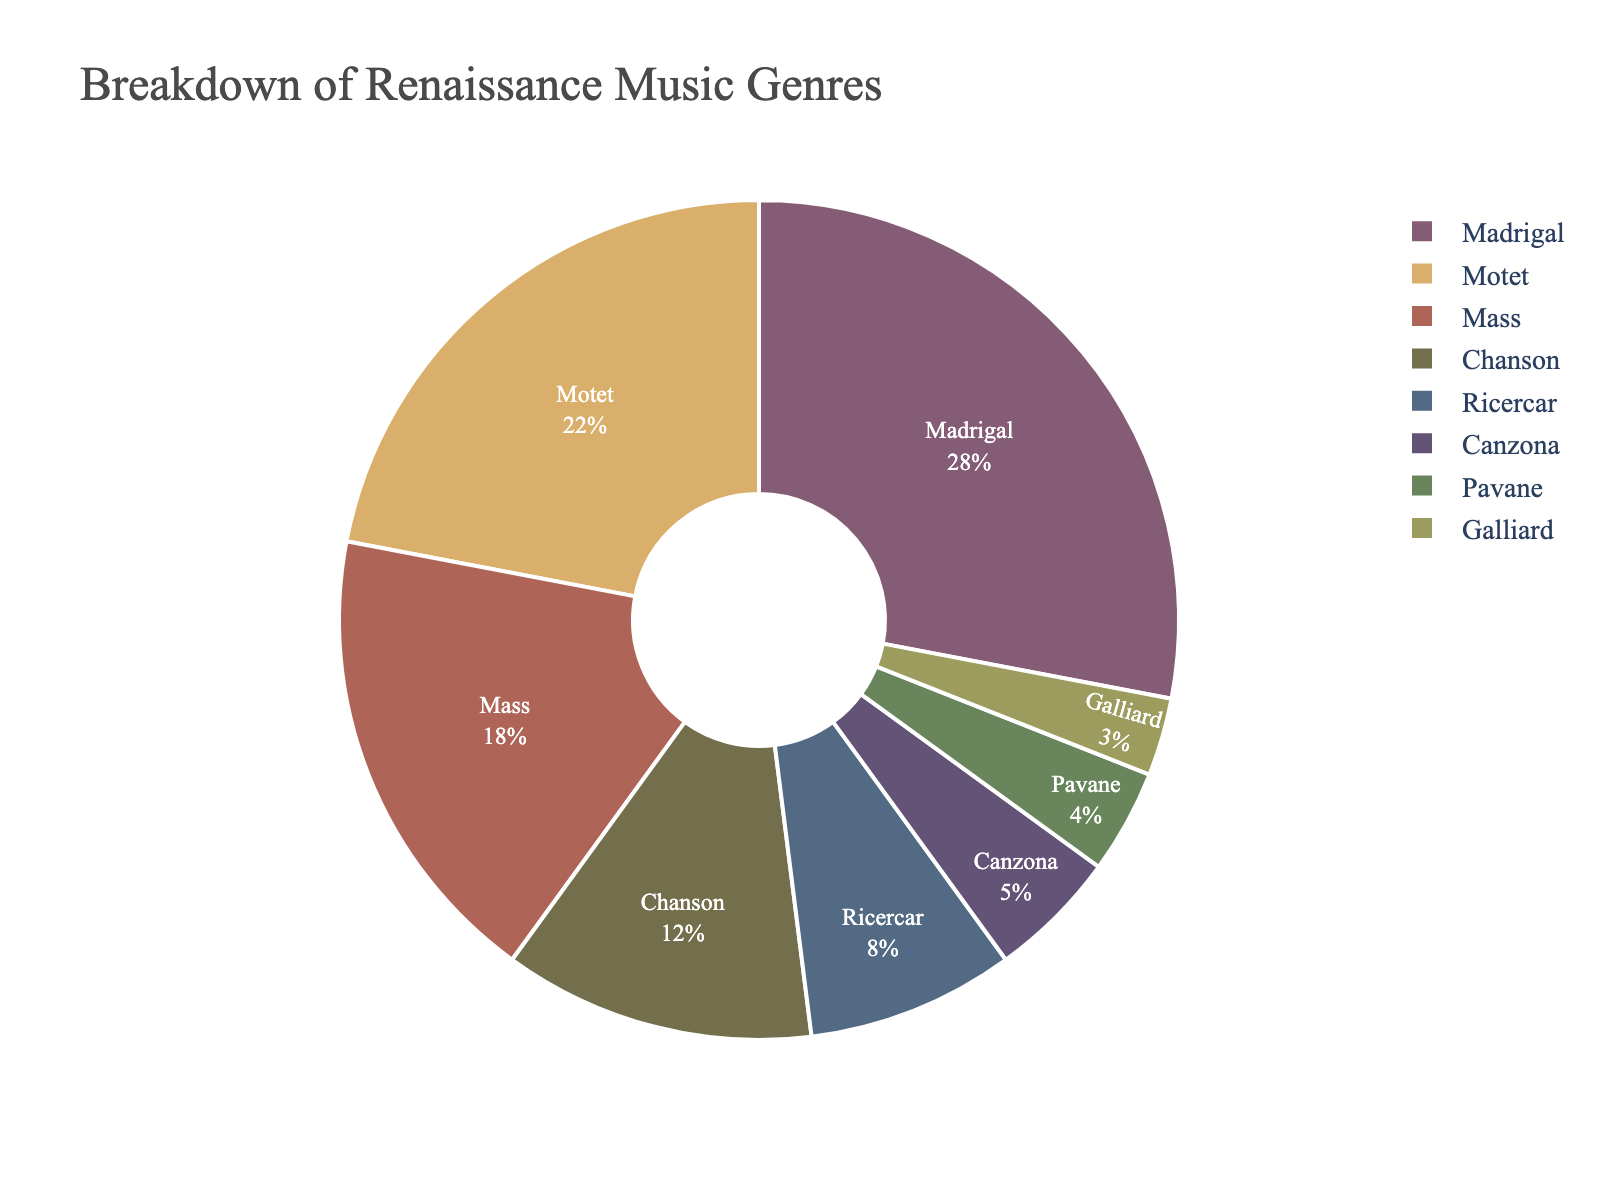Which genre has the highest percentage in the pie chart? The genre with the highest percentage is indicated by the largest slice in the pie chart. In this case, the Madrigal has the largest slice.
Answer: Madrigal What is the combined percentage of Mass and Motet genres? Locate the slices for Mass and Motet. Mass has 18% and Motet has 22%. Add these percentages together: 18% + 22% = 40%.
Answer: 40% Which genre has a smaller percentage, Canzona or Ricercar? Compare the slices for Canzona and Ricercar. Canzona has 5% and Ricercar has 8%. Ricercar has a larger percentage than Canzona.
Answer: Canzona Are there any genres with a percentage less than 4%? Look for slices with a percentage less than 4%. The only genre with a percentage less than 4% is Galliard (3%).
Answer: Yes, Galliard How much larger is the percentage of Madrigal compared to Chanson? The slice for Madrigal is 28% and for Chanson is 12%. Subtract Chanson's percentage from Madrigal's: 28% - 12% = 16%.
Answer: 16% Which genres constitute more than 20% of the chart? Identify slices that are greater than 20%. Madrigal (28%) and Motet (22%) fit this criterion.
Answer: Madrigal and Motet What is the percentage difference between Pavane and Galliard? Locate the slices for Pavane and Galliard. Pavane has 4% and Galliard has 3%. Subtract Galliard's percentage from Pavane's: 4% - 3% = 1%.
Answer: 1% How many genres have a percentage greater than 10% but less than 20%? Identify slices with a percentage greater than 10% and less than 20%. Mass (18%) and Chanson (12%) meet this condition.
Answer: 2 If Ricercar and Canzona were combined into one genre, what would the new percentage be? Add the percentages of Ricercar (8%) and Canzona (5%): 8% + 5% = 13%.
Answer: 13% Do Madrigal and Chanson together make up more than half of the chart? Add the percentages of Madrigal (28%) and Chanson (12%): 28% + 12% = 40%. Since 40% is less than 50%, they do not make up more than half.
Answer: No 